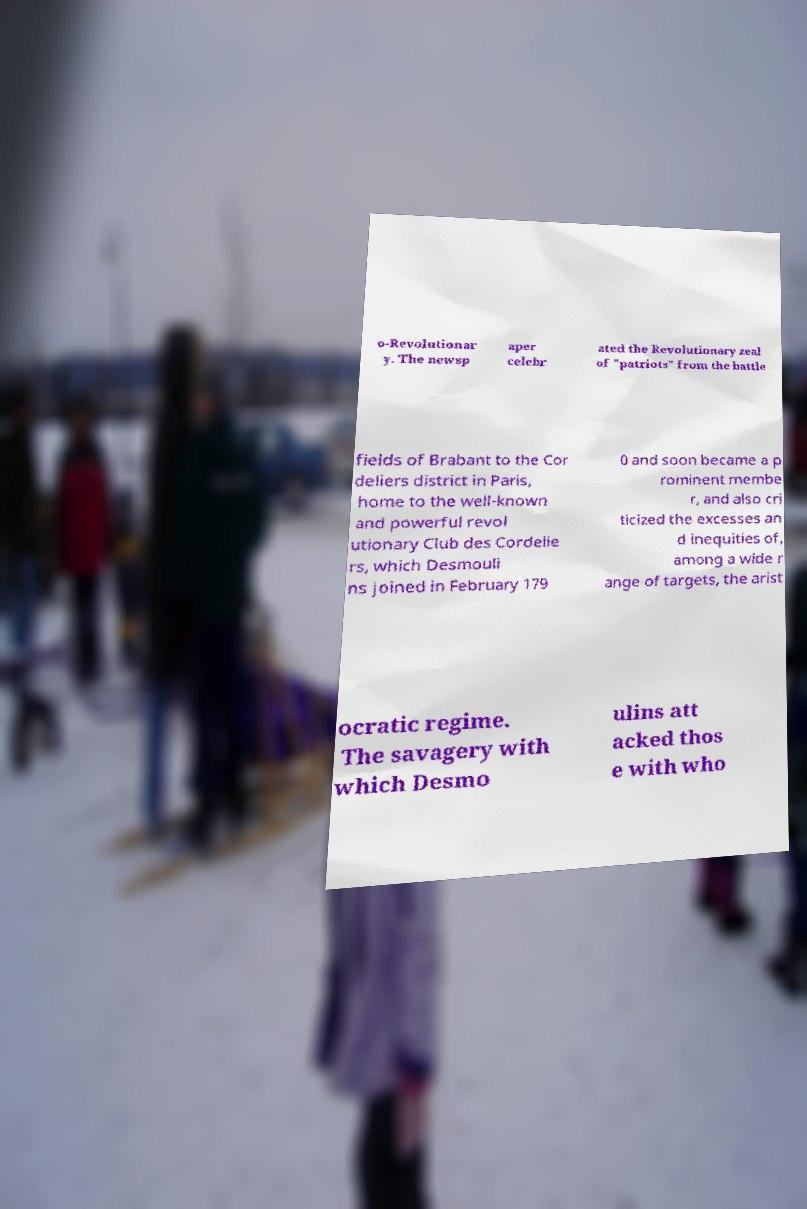For documentation purposes, I need the text within this image transcribed. Could you provide that? o-Revolutionar y. The newsp aper celebr ated the Revolutionary zeal of "patriots" from the battle fields of Brabant to the Cor deliers district in Paris, home to the well-known and powerful revol utionary Club des Cordelie rs, which Desmouli ns joined in February 179 0 and soon became a p rominent membe r, and also cri ticized the excesses an d inequities of, among a wide r ange of targets, the arist ocratic regime. The savagery with which Desmo ulins att acked thos e with who 